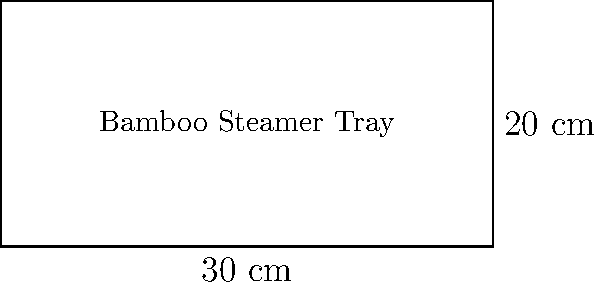You're preparing to make bánh cuốn and need to calculate the amount of fabric needed to line your rectangular bamboo steamer tray. If the tray measures 30 cm in length and 20 cm in width, how much fabric will you need to cover the entire perimeter of the tray? To find the amount of fabric needed to cover the perimeter of the rectangular bamboo steamer tray, we need to calculate its perimeter. The perimeter of a rectangle is the sum of all its sides. Let's break it down step-by-step:

1. Identify the given dimensions:
   Length (l) = 30 cm
   Width (w) = 20 cm

2. Recall the formula for the perimeter of a rectangle:
   Perimeter = 2(length + width) or P = 2(l + w)

3. Substitute the values into the formula:
   P = 2(30 cm + 20 cm)

4. Simplify inside the parentheses:
   P = 2(50 cm)

5. Multiply:
   P = 100 cm

Therefore, you will need 100 cm of fabric to cover the entire perimeter of the bamboo steamer tray.
Answer: 100 cm 